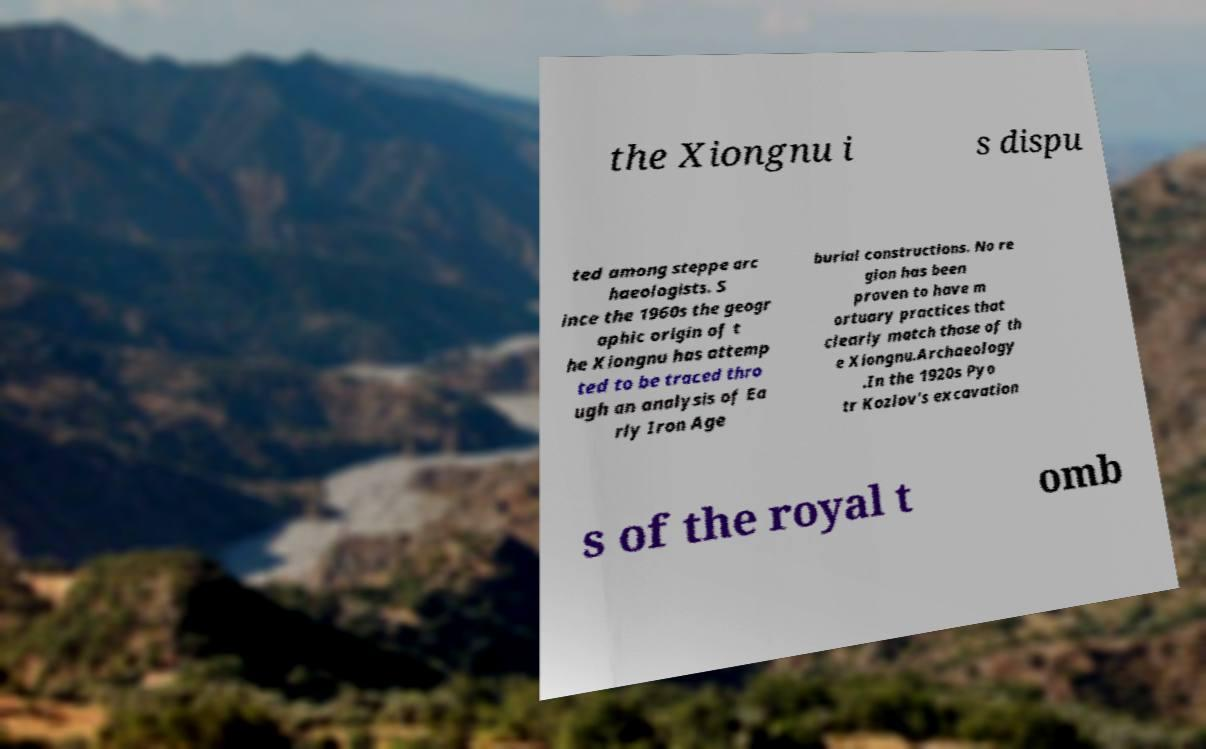Could you extract and type out the text from this image? the Xiongnu i s dispu ted among steppe arc haeologists. S ince the 1960s the geogr aphic origin of t he Xiongnu has attemp ted to be traced thro ugh an analysis of Ea rly Iron Age burial constructions. No re gion has been proven to have m ortuary practices that clearly match those of th e Xiongnu.Archaeology .In the 1920s Pyo tr Kozlov's excavation s of the royal t omb 